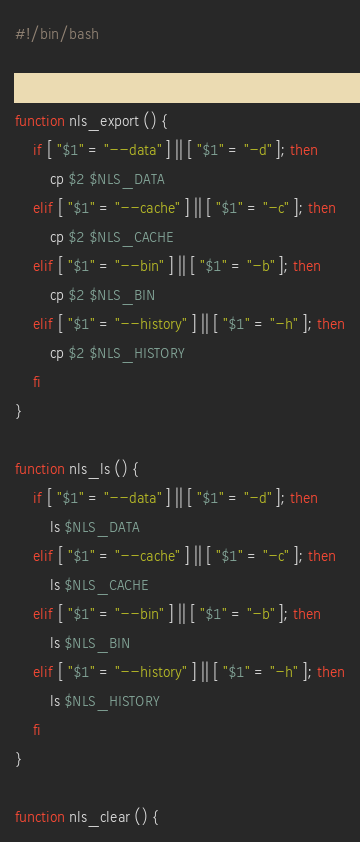Convert code to text. <code><loc_0><loc_0><loc_500><loc_500><_Bash_>#!/bin/bash


function nls_export () {
    if [ "$1" = "--data" ] || [ "$1" = "-d" ]; then
        cp $2 $NLS_DATA
    elif [ "$1" = "--cache" ] || [ "$1" = "-c" ]; then
        cp $2 $NLS_CACHE
    elif [ "$1" = "--bin" ] || [ "$1" = "-b" ]; then
        cp $2 $NLS_BIN
    elif [ "$1" = "--history" ] || [ "$1" = "-h" ]; then
        cp $2 $NLS_HISTORY
    fi
}

function nls_ls () {
    if [ "$1" = "--data" ] || [ "$1" = "-d" ]; then
        ls $NLS_DATA
    elif [ "$1" = "--cache" ] || [ "$1" = "-c" ]; then
        ls $NLS_CACHE
    elif [ "$1" = "--bin" ] || [ "$1" = "-b" ]; then
        ls $NLS_BIN
    elif [ "$1" = "--history" ] || [ "$1" = "-h" ]; then
        ls $NLS_HISTORY
    fi
}

function nls_clear () {</code> 